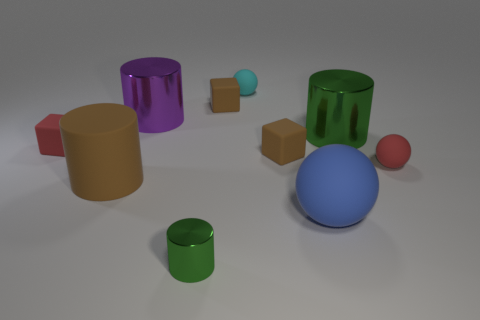How many other things are there of the same material as the brown cylinder?
Ensure brevity in your answer.  6. There is a small red object that is the same shape as the small cyan object; what material is it?
Your response must be concise. Rubber. There is a cylinder that is the same color as the small shiny thing; what is its material?
Your answer should be compact. Metal. What is the material of the large green object?
Provide a succinct answer. Metal. There is a green thing that is the same size as the blue thing; what is its material?
Make the answer very short. Metal. Are there any rubber cubes that have the same size as the rubber cylinder?
Provide a succinct answer. No. Is the number of matte spheres behind the big matte ball the same as the number of big matte spheres on the left side of the purple shiny cylinder?
Ensure brevity in your answer.  No. Are there more small gray matte objects than small rubber balls?
Offer a very short reply. No. What number of matte objects are small red cubes or small spheres?
Provide a succinct answer. 3. What number of small matte objects have the same color as the rubber cylinder?
Offer a very short reply. 2. 